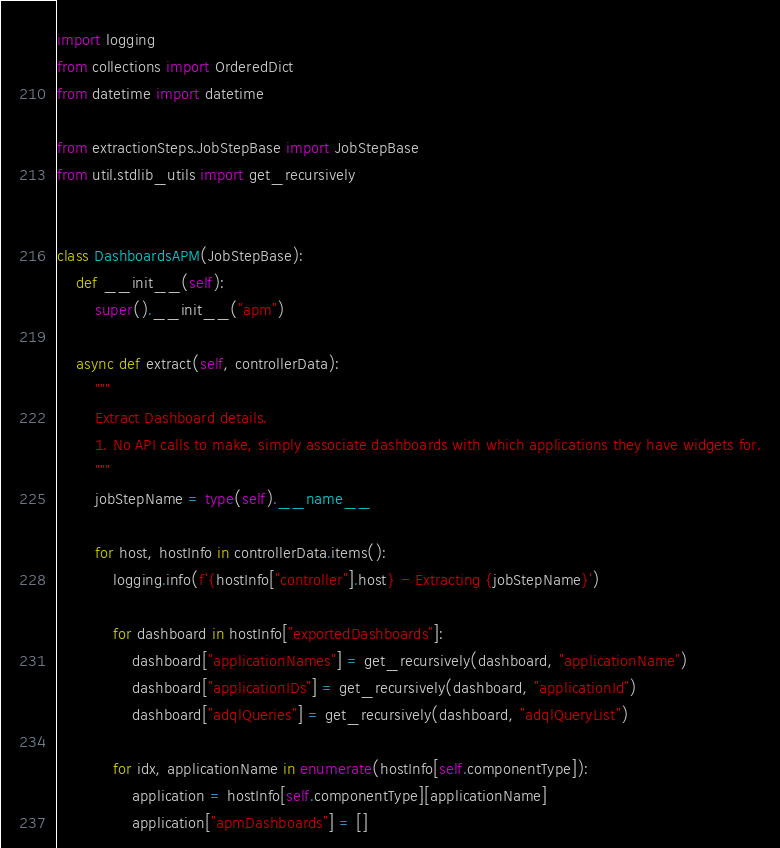Convert code to text. <code><loc_0><loc_0><loc_500><loc_500><_Python_>import logging
from collections import OrderedDict
from datetime import datetime

from extractionSteps.JobStepBase import JobStepBase
from util.stdlib_utils import get_recursively


class DashboardsAPM(JobStepBase):
    def __init__(self):
        super().__init__("apm")

    async def extract(self, controllerData):
        """
        Extract Dashboard details.
        1. No API calls to make, simply associate dashboards with which applications they have widgets for.
        """
        jobStepName = type(self).__name__

        for host, hostInfo in controllerData.items():
            logging.info(f'{hostInfo["controller"].host} - Extracting {jobStepName}')

            for dashboard in hostInfo["exportedDashboards"]:
                dashboard["applicationNames"] = get_recursively(dashboard, "applicationName")
                dashboard["applicationIDs"] = get_recursively(dashboard, "applicationId")
                dashboard["adqlQueries"] = get_recursively(dashboard, "adqlQueryList")

            for idx, applicationName in enumerate(hostInfo[self.componentType]):
                application = hostInfo[self.componentType][applicationName]
                application["apmDashboards"] = []</code> 